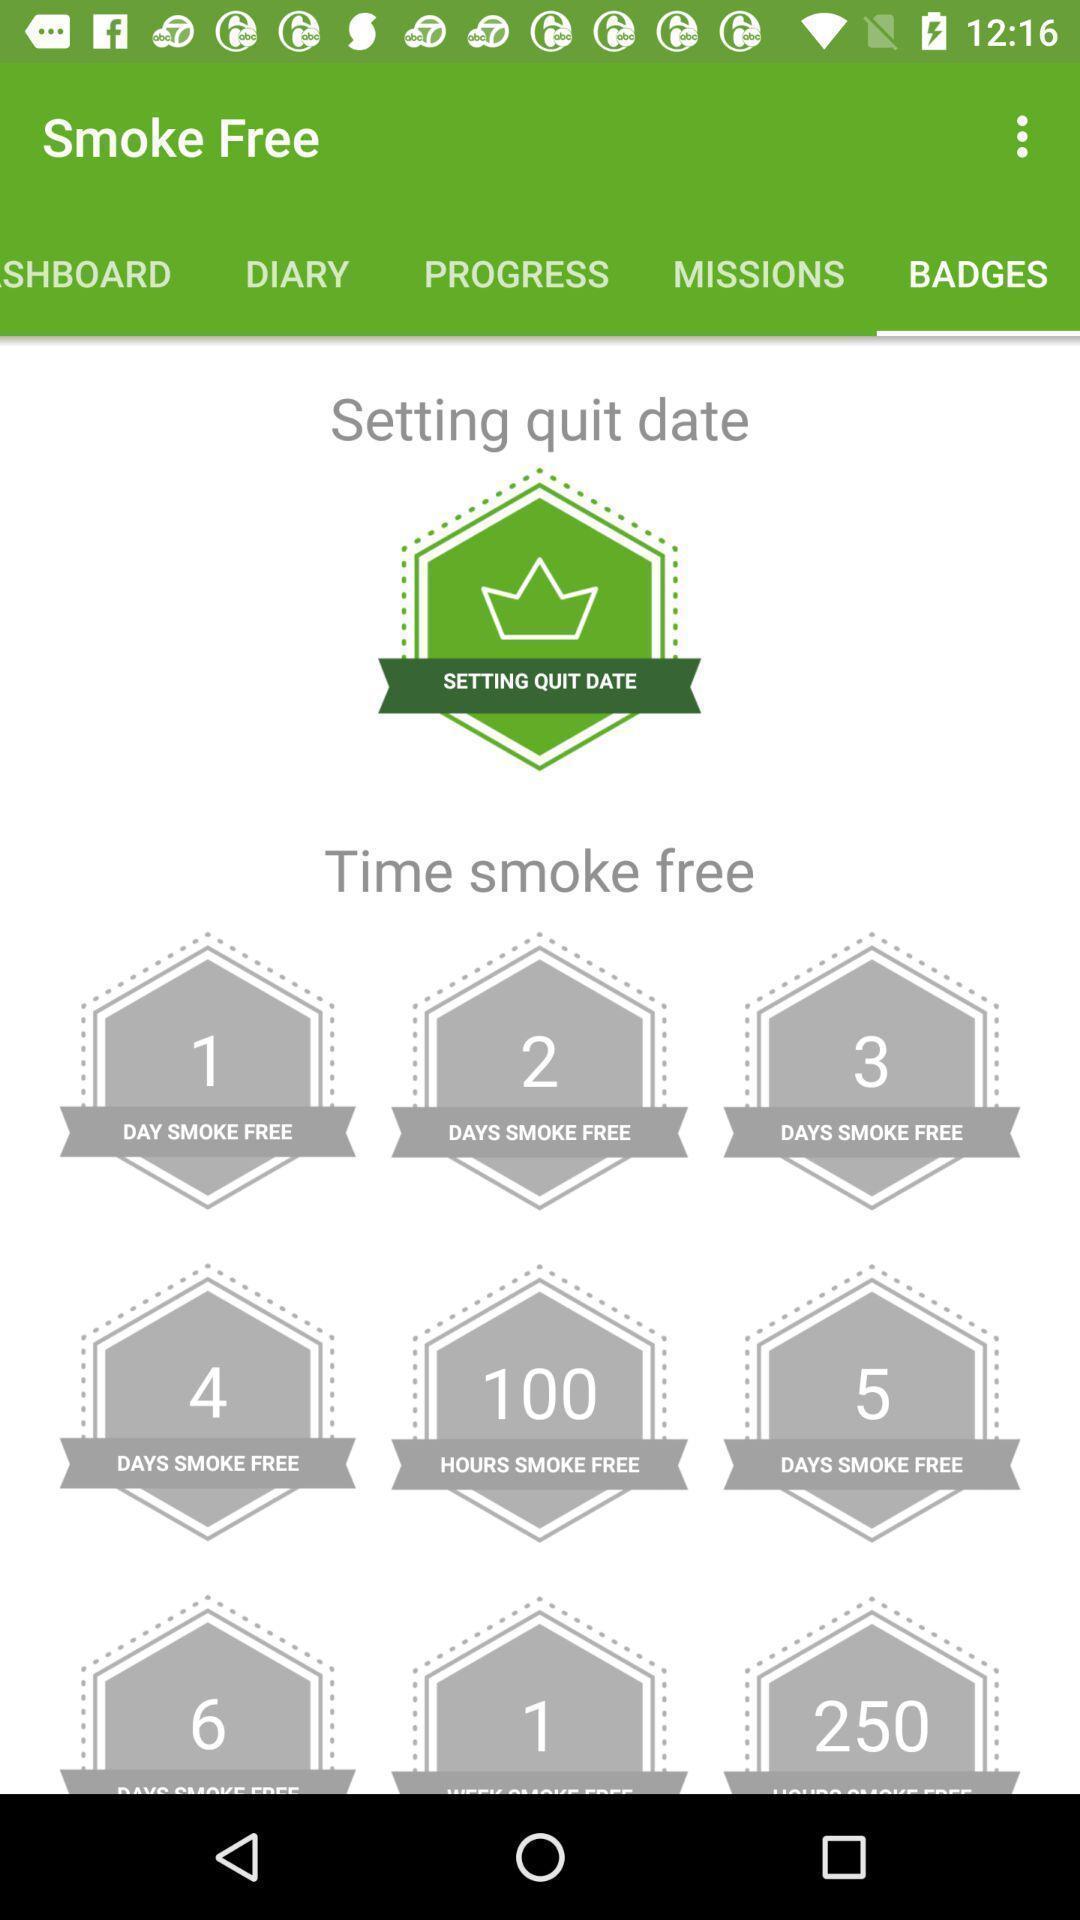Explain the elements present in this screenshot. Screen displaying badges page. 